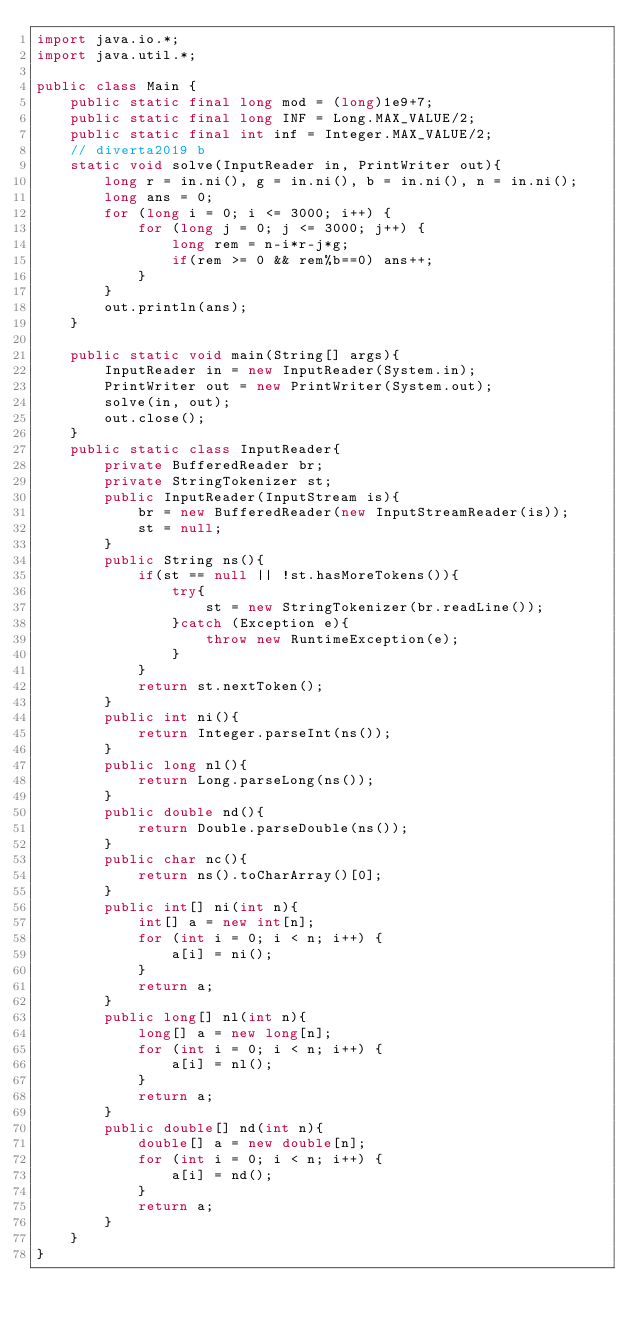Convert code to text. <code><loc_0><loc_0><loc_500><loc_500><_Java_>import java.io.*;
import java.util.*;

public class Main {
    public static final long mod = (long)1e9+7;
    public static final long INF = Long.MAX_VALUE/2;
    public static final int inf = Integer.MAX_VALUE/2;
    // diverta2019 b
    static void solve(InputReader in, PrintWriter out){
        long r = in.ni(), g = in.ni(), b = in.ni(), n = in.ni();
        long ans = 0;
        for (long i = 0; i <= 3000; i++) {
            for (long j = 0; j <= 3000; j++) {
                long rem = n-i*r-j*g;
                if(rem >= 0 && rem%b==0) ans++;
            }
        }
        out.println(ans);
    }

    public static void main(String[] args){
        InputReader in = new InputReader(System.in);
        PrintWriter out = new PrintWriter(System.out);
        solve(in, out);
        out.close();
    }
    public static class InputReader{
        private BufferedReader br;
        private StringTokenizer st;
        public InputReader(InputStream is){
            br = new BufferedReader(new InputStreamReader(is));
            st = null;
        }
        public String ns(){
            if(st == null || !st.hasMoreTokens()){
                try{
                    st = new StringTokenizer(br.readLine());
                }catch (Exception e){
                    throw new RuntimeException(e);
                }
            }
            return st.nextToken();
        }
        public int ni(){
            return Integer.parseInt(ns());
        }
        public long nl(){
            return Long.parseLong(ns());
        }
        public double nd(){
            return Double.parseDouble(ns());
        }
        public char nc(){
            return ns().toCharArray()[0];
        }
        public int[] ni(int n){
            int[] a = new int[n];
            for (int i = 0; i < n; i++) {
                a[i] = ni();
            }
            return a;
        }
        public long[] nl(int n){
            long[] a = new long[n];
            for (int i = 0; i < n; i++) {
                a[i] = nl();
            }
            return a;
        }
        public double[] nd(int n){
            double[] a = new double[n];
            for (int i = 0; i < n; i++) {
                a[i] = nd();
            }
            return a;
        }
    }
}</code> 